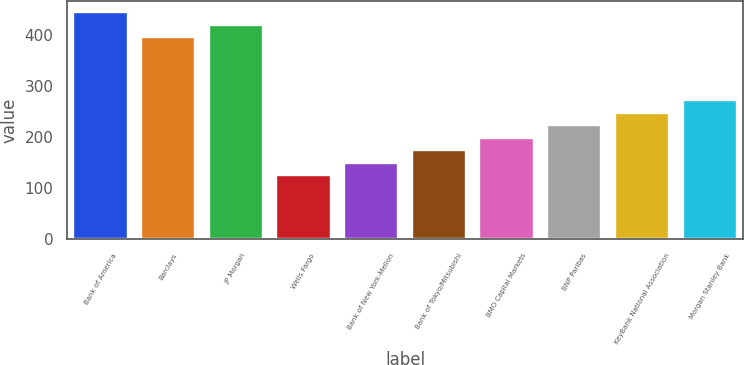Convert chart. <chart><loc_0><loc_0><loc_500><loc_500><bar_chart><fcel>Bank of America<fcel>Barclays<fcel>JP Morgan<fcel>Wells Fargo<fcel>Bank of New York-Mellon<fcel>Bank of Tokyo/Mitsubishi<fcel>BMO Capital Markets<fcel>BNP Paribas<fcel>KeyBank National Association<fcel>Morgan Stanley Bank<nl><fcel>443.95<fcel>394.93<fcel>419.44<fcel>125.32<fcel>149.83<fcel>174.34<fcel>198.85<fcel>223.36<fcel>247.87<fcel>272.38<nl></chart> 